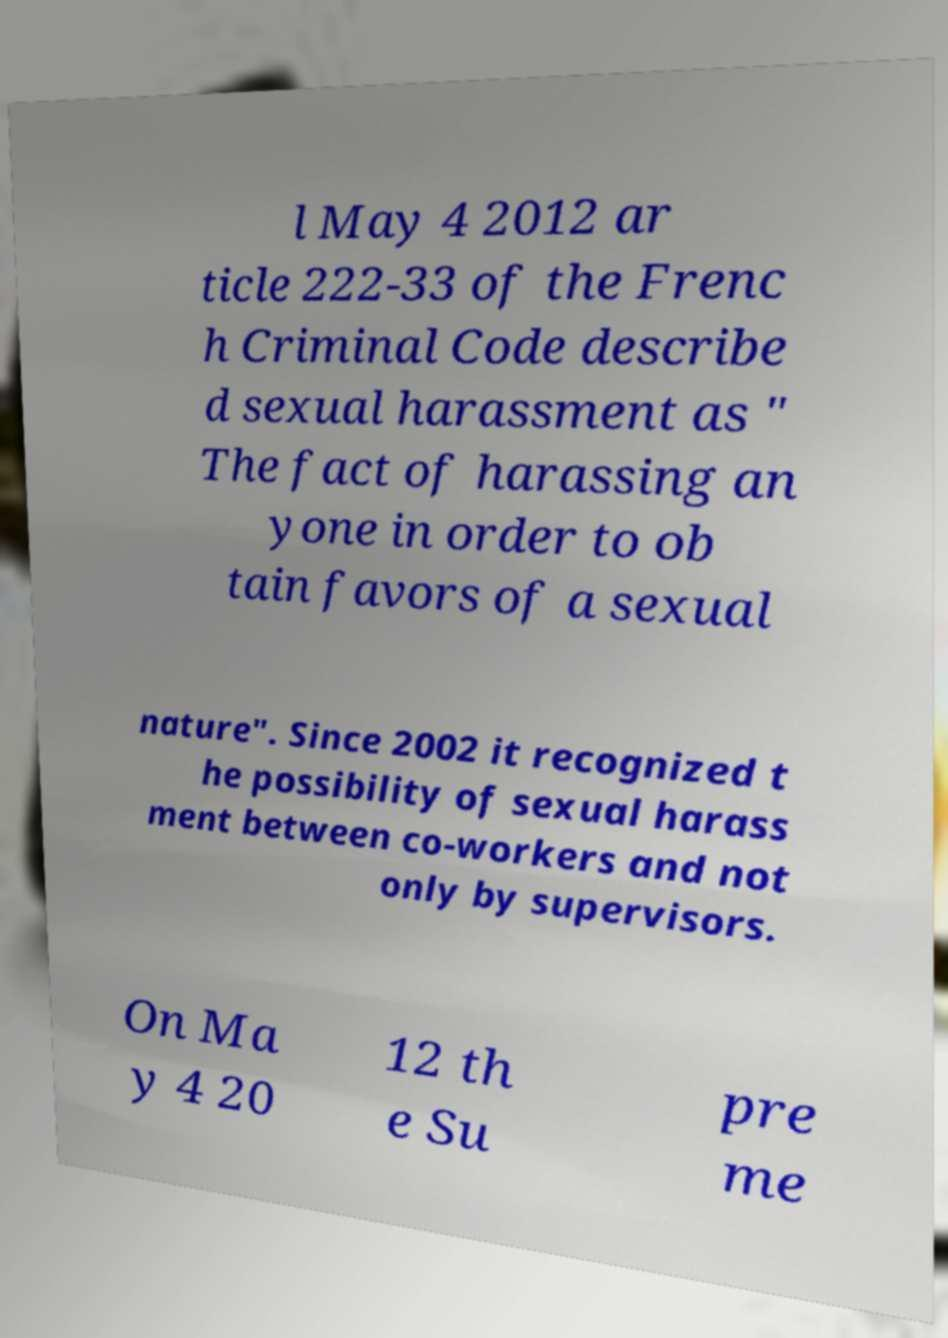For documentation purposes, I need the text within this image transcribed. Could you provide that? l May 4 2012 ar ticle 222-33 of the Frenc h Criminal Code describe d sexual harassment as " The fact of harassing an yone in order to ob tain favors of a sexual nature". Since 2002 it recognized t he possibility of sexual harass ment between co-workers and not only by supervisors. On Ma y 4 20 12 th e Su pre me 